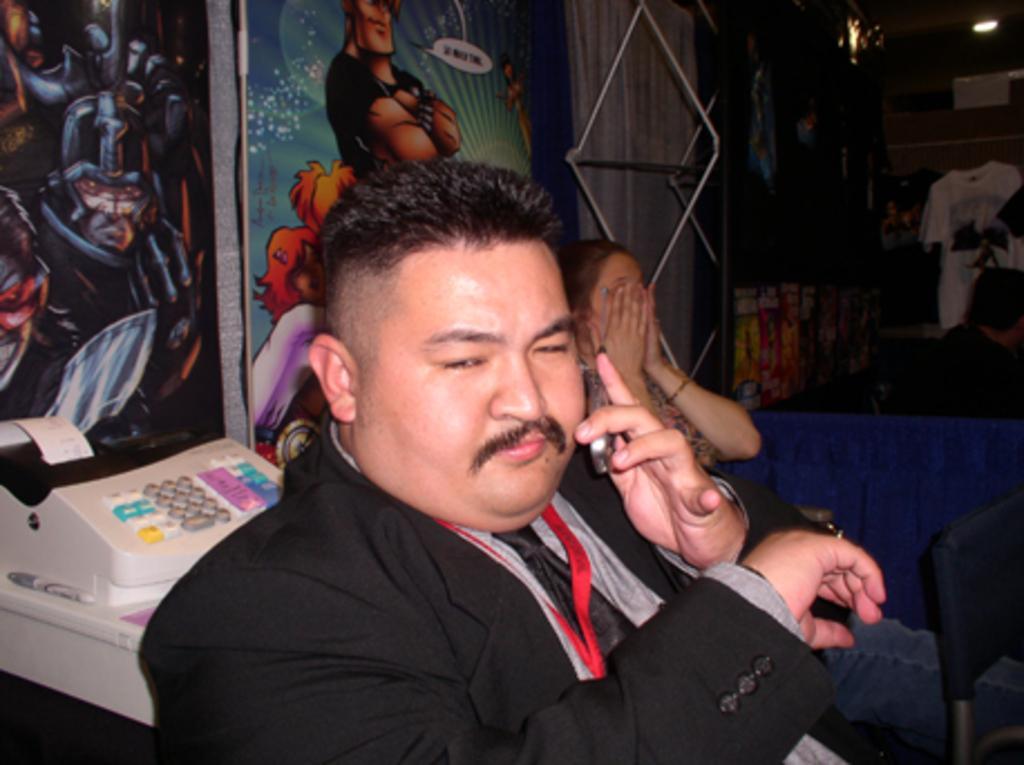Can you describe this image briefly? In the center of the image there is a person holding mobile phone. In the background we can see person, t-shirt, wall, door, prints and posters. 